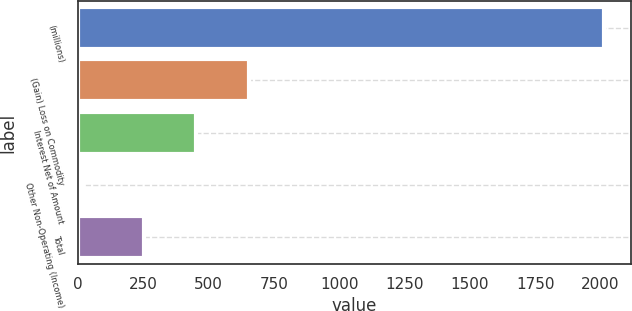Convert chart to OTSL. <chart><loc_0><loc_0><loc_500><loc_500><bar_chart><fcel>(millions)<fcel>(Gain) Loss on Commodity<fcel>Interest Net of Amount<fcel>Other Non-Operating (Income)<fcel>Total<nl><fcel>2015<fcel>653<fcel>453<fcel>15<fcel>253<nl></chart> 